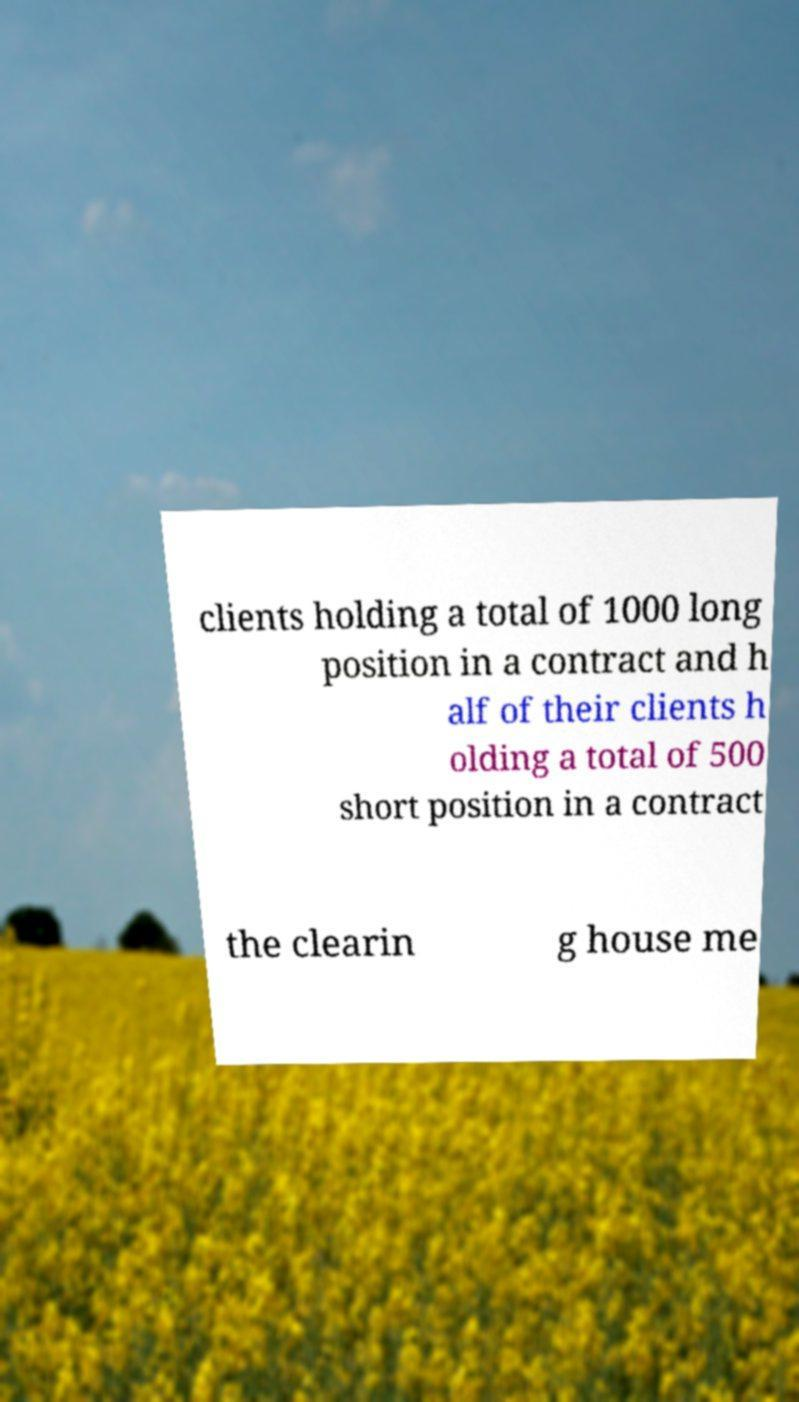What messages or text are displayed in this image? I need them in a readable, typed format. clients holding a total of 1000 long position in a contract and h alf of their clients h olding a total of 500 short position in a contract the clearin g house me 